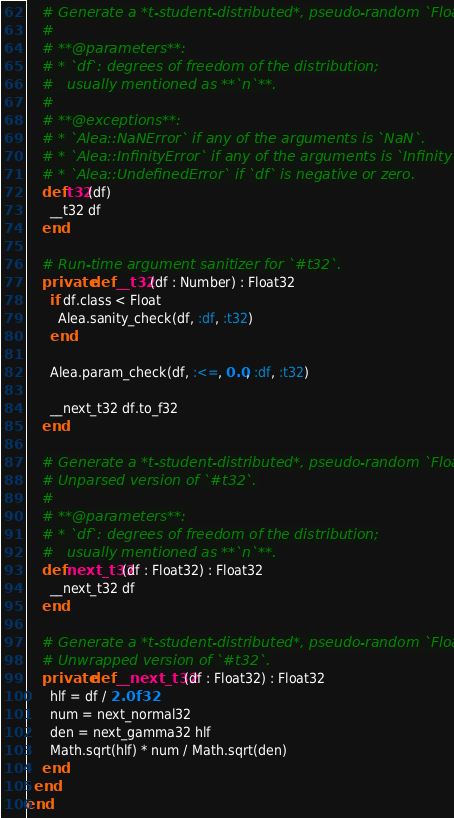<code> <loc_0><loc_0><loc_500><loc_500><_Crystal_>
    # Generate a *t-student-distributed*, pseudo-random `Float32`.
    #
    # **@parameters**:
    # * `df`: degrees of freedom of the distribution;
    #   usually mentioned as **`n`**.
    #
    # **@exceptions**:
    # * `Alea::NaNError` if any of the arguments is `NaN`.
    # * `Alea::InfinityError` if any of the arguments is `Infinity`.
    # * `Alea::UndefinedError` if `df` is negative or zero.
    def t32(df)
      __t32 df
    end

    # Run-time argument sanitizer for `#t32`.
    private def __t32(df : Number) : Float32
      if df.class < Float
        Alea.sanity_check(df, :df, :t32)
      end

      Alea.param_check(df, :<=, 0.0, :df, :t32)

      __next_t32 df.to_f32
    end

    # Generate a *t-student-distributed*, pseudo-random `Float32`.
    # Unparsed version of `#t32`.
    #
    # **@parameters**:
    # * `df`: degrees of freedom of the distribution;
    #   usually mentioned as **`n`**.
    def next_t32(df : Float32) : Float32
      __next_t32 df
    end

    # Generate a *t-student-distributed*, pseudo-random `Float32`.
    # Unwrapped version of `#t32`.
    private def __next_t32(df : Float32) : Float32
      hlf = df / 2.0f32
      num = next_normal32
      den = next_gamma32 hlf
      Math.sqrt(hlf) * num / Math.sqrt(den)
    end
  end
end
</code> 